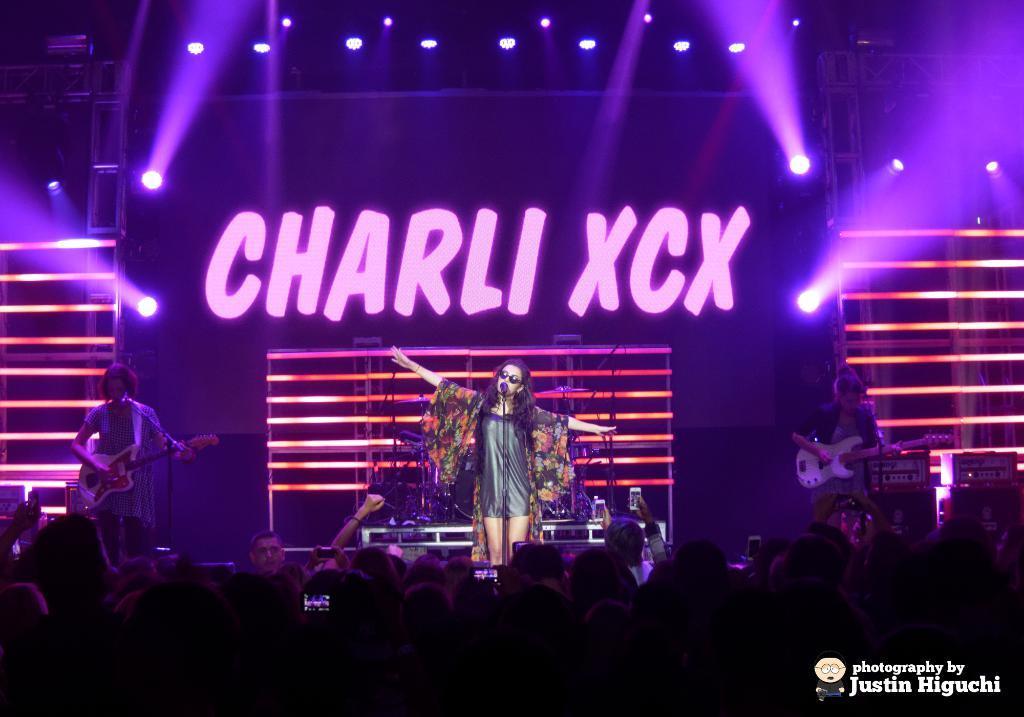Could you give a brief overview of what you see in this image? In this picture there is a girls, standing on the stage and singing in the microphone. Behind there are some lights on the stage. In the front bottom side we can see the audience sitting and enjoying the show. On the top there is iron frame with spot lights. 